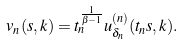Convert formula to latex. <formula><loc_0><loc_0><loc_500><loc_500>v _ { n } ( s , k ) = t _ { n } ^ { \frac { 1 } { \beta - 1 } } u ^ { ( n ) } _ { \delta _ { n } } ( t _ { n } s , k ) .</formula> 